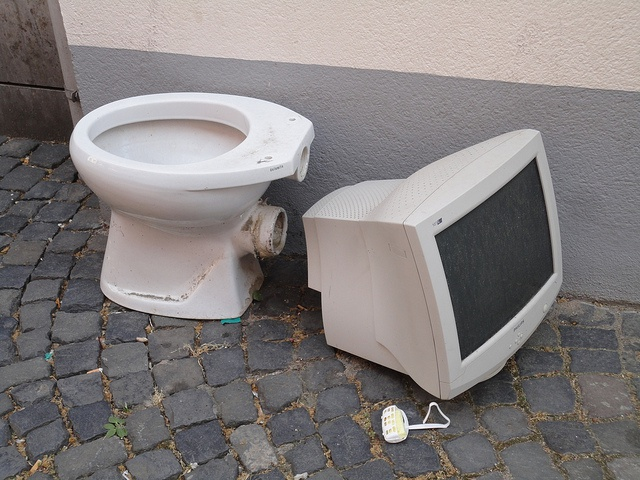Describe the objects in this image and their specific colors. I can see tv in gray, darkgray, black, and lightgray tones and toilet in gray, lightgray, and darkgray tones in this image. 